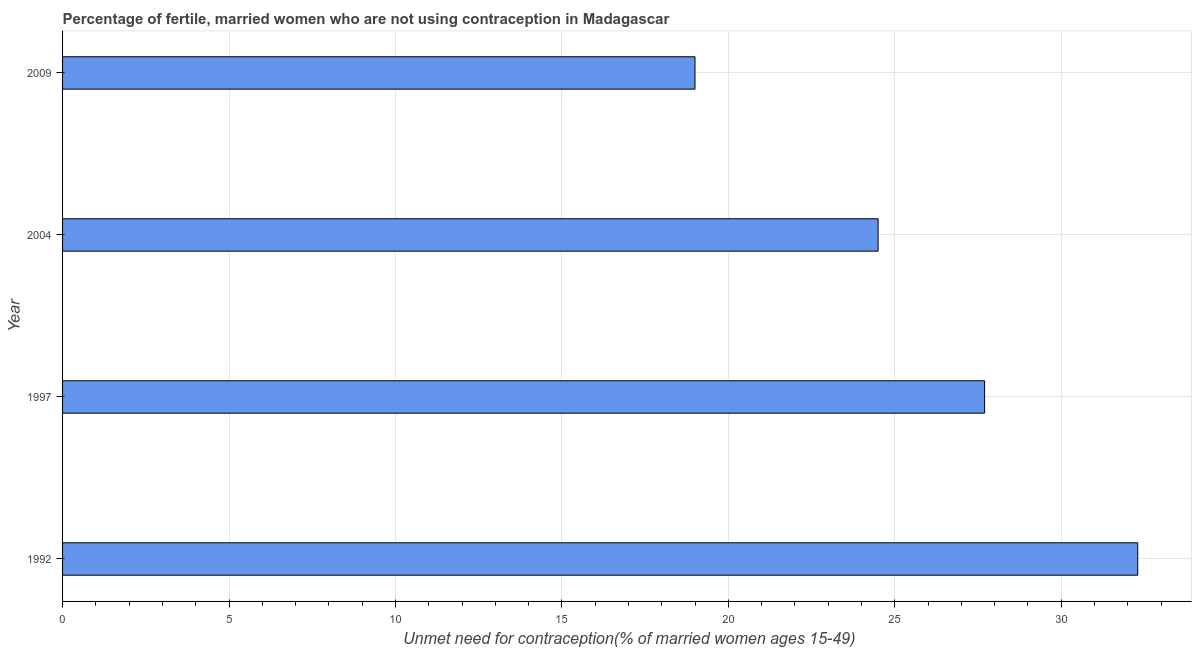Does the graph contain any zero values?
Your answer should be compact. No. What is the title of the graph?
Your answer should be compact. Percentage of fertile, married women who are not using contraception in Madagascar. What is the label or title of the X-axis?
Offer a terse response.  Unmet need for contraception(% of married women ages 15-49). What is the number of married women who are not using contraception in 2004?
Ensure brevity in your answer.  24.5. Across all years, what is the maximum number of married women who are not using contraception?
Offer a very short reply. 32.3. In which year was the number of married women who are not using contraception maximum?
Keep it short and to the point. 1992. In which year was the number of married women who are not using contraception minimum?
Offer a terse response. 2009. What is the sum of the number of married women who are not using contraception?
Ensure brevity in your answer.  103.5. What is the average number of married women who are not using contraception per year?
Your answer should be compact. 25.88. What is the median number of married women who are not using contraception?
Give a very brief answer. 26.1. What is the ratio of the number of married women who are not using contraception in 1992 to that in 1997?
Provide a short and direct response. 1.17. What is the difference between the highest and the second highest number of married women who are not using contraception?
Keep it short and to the point. 4.6. In how many years, is the number of married women who are not using contraception greater than the average number of married women who are not using contraception taken over all years?
Offer a terse response. 2. How many bars are there?
Give a very brief answer. 4. What is the difference between two consecutive major ticks on the X-axis?
Keep it short and to the point. 5. What is the  Unmet need for contraception(% of married women ages 15-49) of 1992?
Make the answer very short. 32.3. What is the  Unmet need for contraception(% of married women ages 15-49) of 1997?
Provide a short and direct response. 27.7. What is the  Unmet need for contraception(% of married women ages 15-49) in 2004?
Your answer should be very brief. 24.5. What is the  Unmet need for contraception(% of married women ages 15-49) of 2009?
Make the answer very short. 19. What is the difference between the  Unmet need for contraception(% of married women ages 15-49) in 1992 and 1997?
Your answer should be very brief. 4.6. What is the difference between the  Unmet need for contraception(% of married women ages 15-49) in 1997 and 2004?
Provide a succinct answer. 3.2. What is the difference between the  Unmet need for contraception(% of married women ages 15-49) in 1997 and 2009?
Provide a short and direct response. 8.7. What is the difference between the  Unmet need for contraception(% of married women ages 15-49) in 2004 and 2009?
Keep it short and to the point. 5.5. What is the ratio of the  Unmet need for contraception(% of married women ages 15-49) in 1992 to that in 1997?
Your answer should be very brief. 1.17. What is the ratio of the  Unmet need for contraception(% of married women ages 15-49) in 1992 to that in 2004?
Keep it short and to the point. 1.32. What is the ratio of the  Unmet need for contraception(% of married women ages 15-49) in 1992 to that in 2009?
Your answer should be compact. 1.7. What is the ratio of the  Unmet need for contraception(% of married women ages 15-49) in 1997 to that in 2004?
Your answer should be compact. 1.13. What is the ratio of the  Unmet need for contraception(% of married women ages 15-49) in 1997 to that in 2009?
Your answer should be compact. 1.46. What is the ratio of the  Unmet need for contraception(% of married women ages 15-49) in 2004 to that in 2009?
Provide a succinct answer. 1.29. 